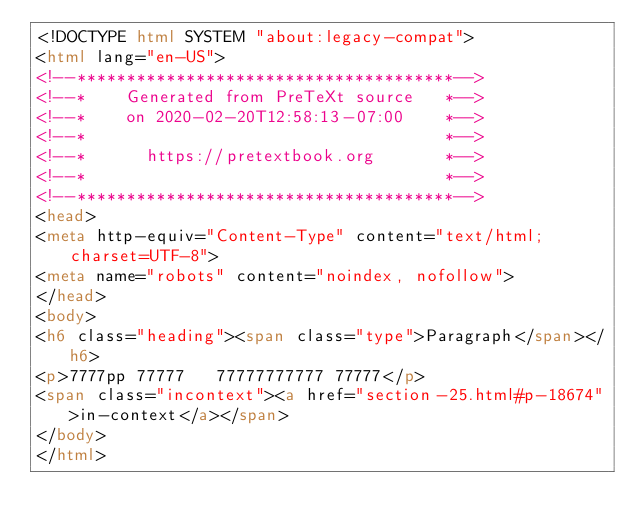Convert code to text. <code><loc_0><loc_0><loc_500><loc_500><_HTML_><!DOCTYPE html SYSTEM "about:legacy-compat">
<html lang="en-US">
<!--**************************************-->
<!--*    Generated from PreTeXt source   *-->
<!--*    on 2020-02-20T12:58:13-07:00    *-->
<!--*                                    *-->
<!--*      https://pretextbook.org       *-->
<!--*                                    *-->
<!--**************************************-->
<head>
<meta http-equiv="Content-Type" content="text/html; charset=UTF-8">
<meta name="robots" content="noindex, nofollow">
</head>
<body>
<h6 class="heading"><span class="type">Paragraph</span></h6>
<p>7777pp 77777   77777777777 77777</p>
<span class="incontext"><a href="section-25.html#p-18674">in-context</a></span>
</body>
</html>
</code> 